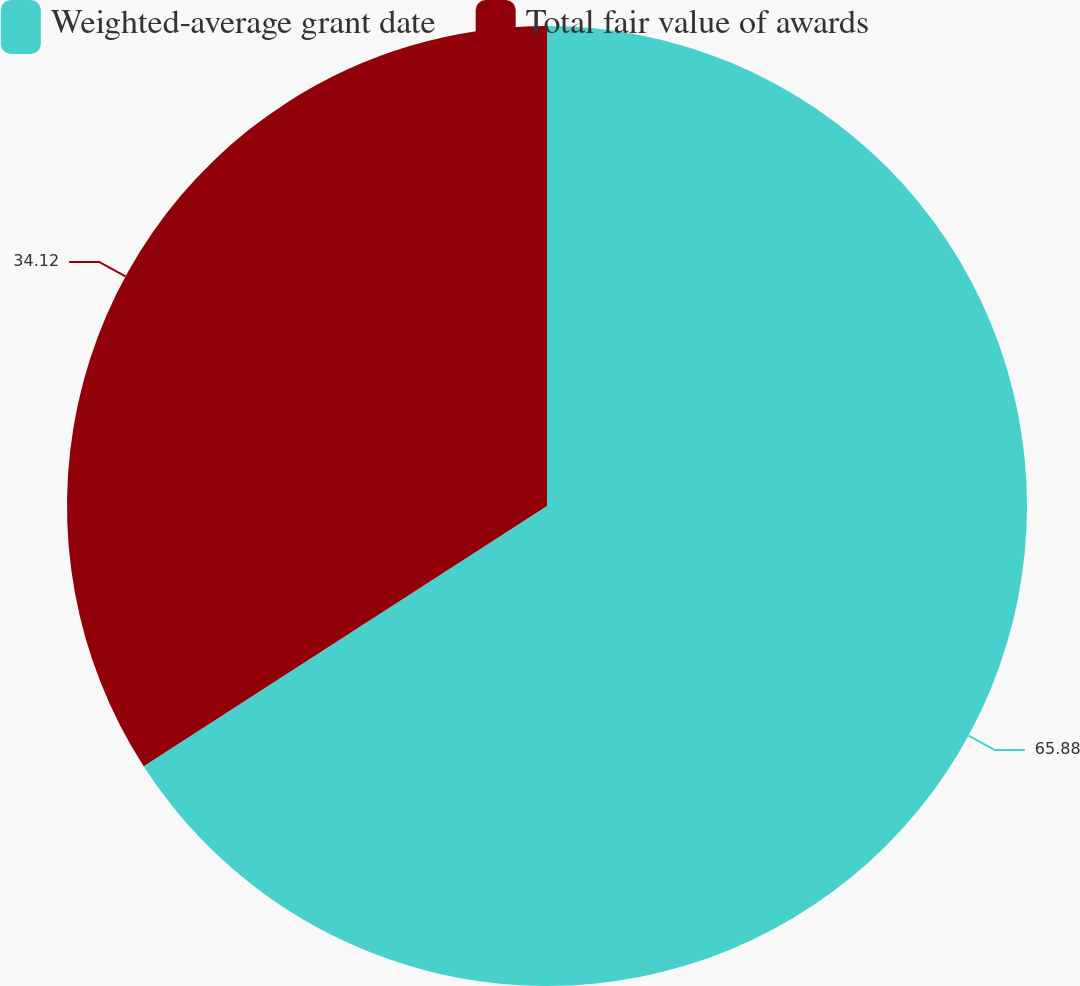Convert chart. <chart><loc_0><loc_0><loc_500><loc_500><pie_chart><fcel>Weighted-average grant date<fcel>Total fair value of awards<nl><fcel>65.88%<fcel>34.12%<nl></chart> 